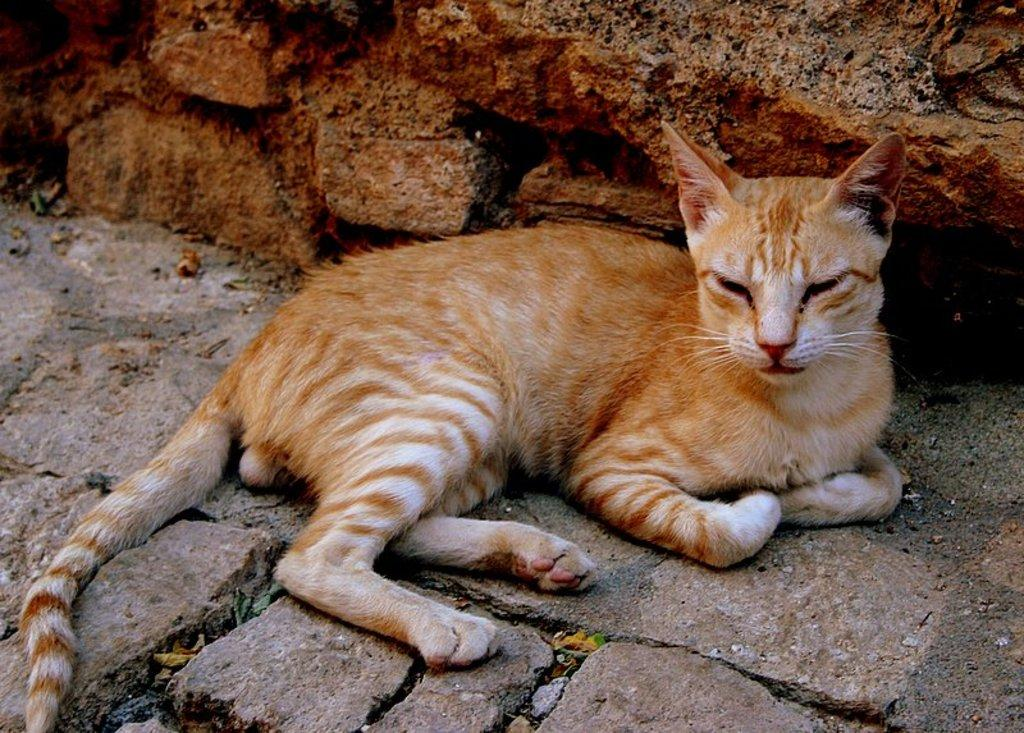What type of animal is in the image? There is a cat in the image. What is located behind the cat in the image? There is a rock behind the cat in the image. Can you see any potatoes near the seashore in the image? There is no seashore or potatoes present in the image. 